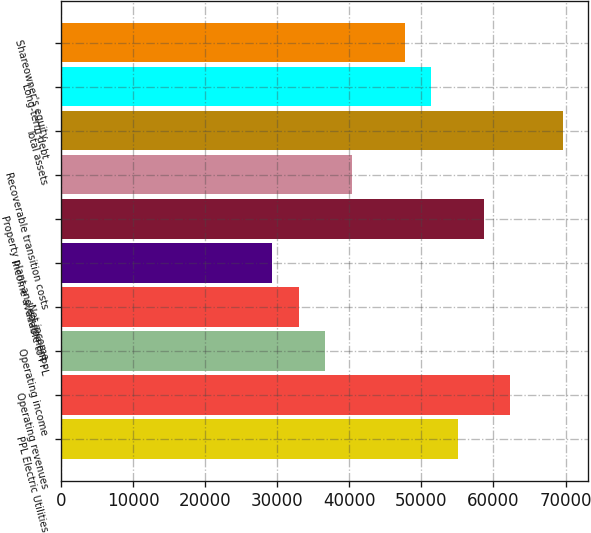Convert chart to OTSL. <chart><loc_0><loc_0><loc_500><loc_500><bar_chart><fcel>PPL Electric Utilities<fcel>Operating revenues<fcel>Operating income<fcel>Net income<fcel>Income available to PPL<fcel>Property plant and equipment -<fcel>Recoverable transition costs<fcel>Total assets<fcel>Long-term debt<fcel>Shareowner's equity<nl><fcel>55023.2<fcel>62359.3<fcel>36683<fcel>33014.9<fcel>29346.9<fcel>58691.3<fcel>40351.1<fcel>69695.4<fcel>51355.2<fcel>47687.2<nl></chart> 